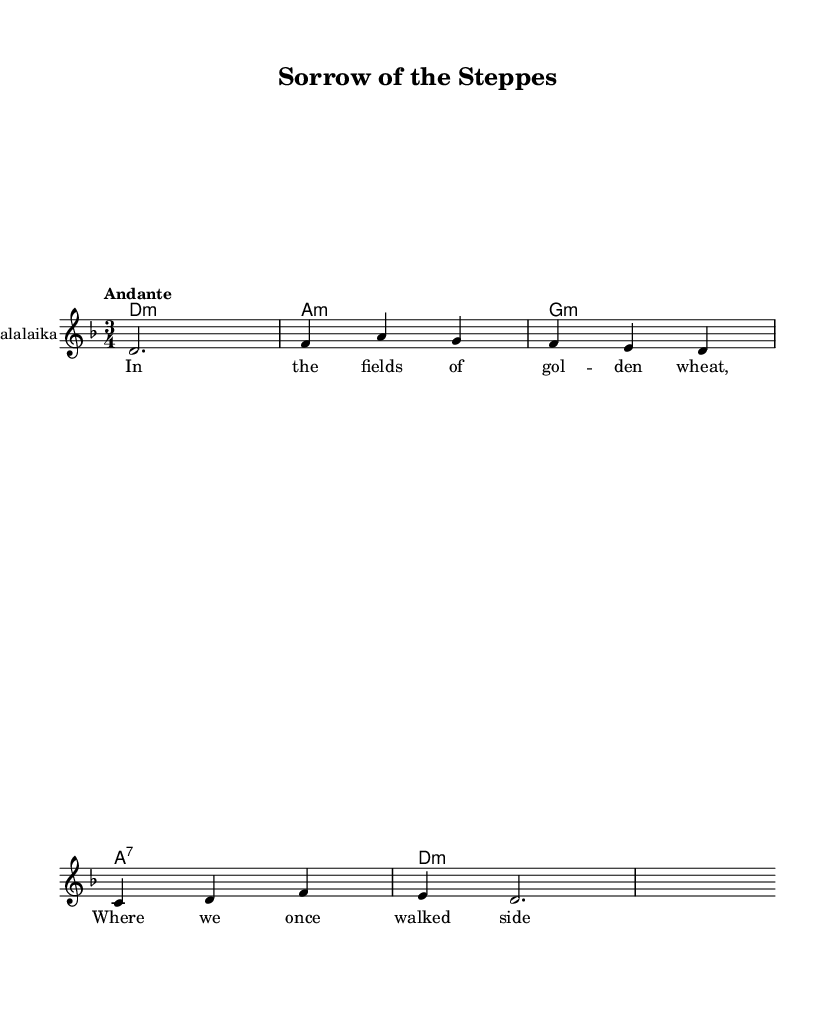What is the key signature of this music? The key signature is D minor, which has one flat (B flat). This can be identified from the key signature indicated at the beginning of the music sheet, which normally displays the necessary sharps or flats.
Answer: D minor What is the time signature of this music? The time signature is 3/4, which indicates that there are three beats in each measure and the quarter note receives one beat. This is shown at the beginning of the score next to the key signature.
Answer: 3/4 What is the tempo marking for this piece? The tempo marking is "Andante," meaning it is meant to be played at a moderate pace. This is specified near the beginning of the score, indicating how fast the music should be played.
Answer: Andante How many measures are there in the melody? There are eight measures in the melody, as indicated by the number of distinct groups of notes separated by vertical lines (bar lines) throughout the score.
Answer: 8 Which instrument is indicated to perform the melody? The melody is indicated to be performed by a Balalaika, which is stated in the instrument name on the staff. This information shows what kind of instrument should play the notes written.
Answer: Balalaika What theme is reflected in the lyrics provided? The theme reflected in the lyrics is love and loss, as it refers to memories shared in the fields and evokes a sense of nostalgia and sorrow. This can be inferred from the lyrical content provided with the music.
Answer: Love and loss What type of chord is used in the first measure? The first measure contains a D minor chord, as indicated in the harmonies section where it shows the corresponding chord symbols above the melody.
Answer: D minor 